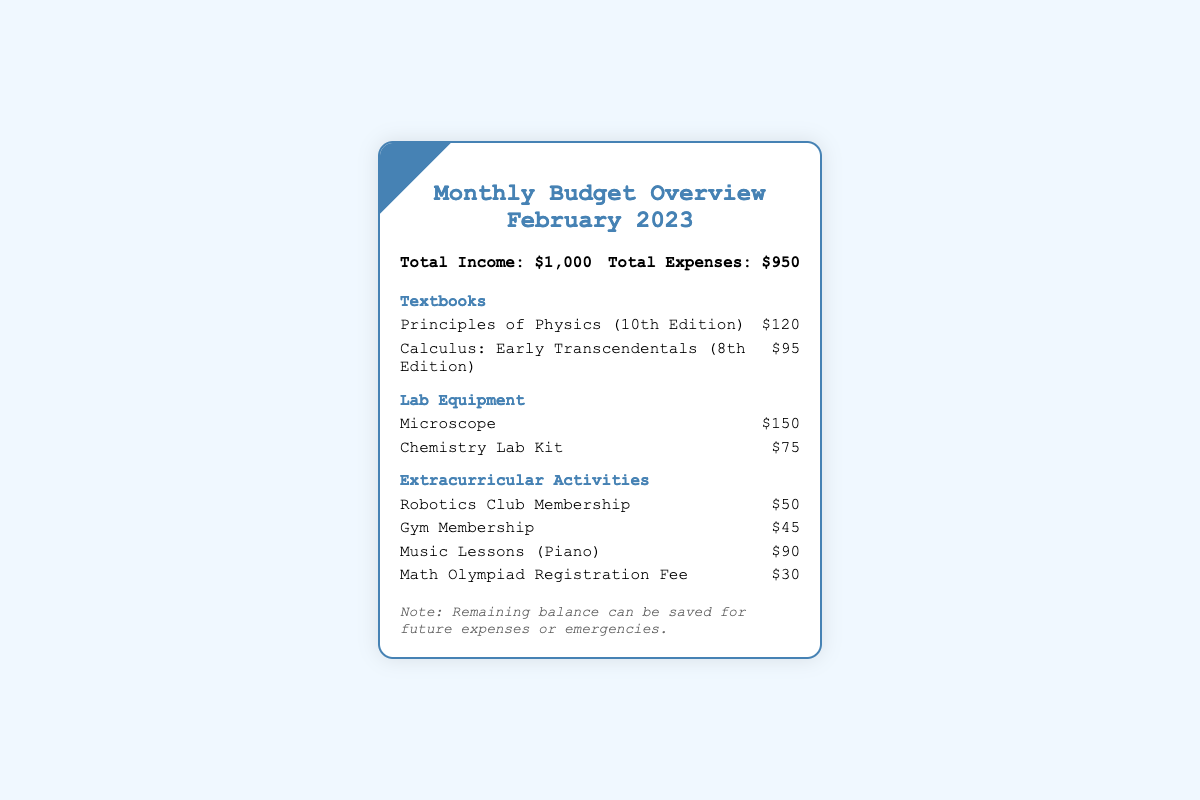What is the total income for February 2023? The total income is specified in the budget overview section of the document as $1,000.
Answer: $1,000 How much was spent on textbooks? The total expense on textbooks is calculated by summing the costs of individual textbooks, which are $120 + $95.
Answer: $215 What is the price of the microscope? The price of the microscope is listed under lab equipment expenses.
Answer: $150 How many extracurricular activities are listed? The document lists a total of four extracurricular activities under their category.
Answer: 4 What is the amount spent on the Math Olympiad Registration Fee? The expense for the Math Olympiad Registration Fee is specified under extracurricular activities.
Answer: $30 What is the remaining balance after expenses? The remaining balance is determined by subtracting total expenses from total income, which is $1,000 - $950.
Answer: $50 How much does the Gym Membership cost? The cost of the Gym Membership is provided in the extracurricular activities section.
Answer: $45 What edition is the "Calculus: Early Transcendentals"? The edition of "Calculus: Early Transcendentals" is specified in the expenses section.
Answer: 8th Edition What is noted about the remaining balance? The document includes a note on the purpose for the remaining balance.
Answer: Savings for future expenses or emergencies 